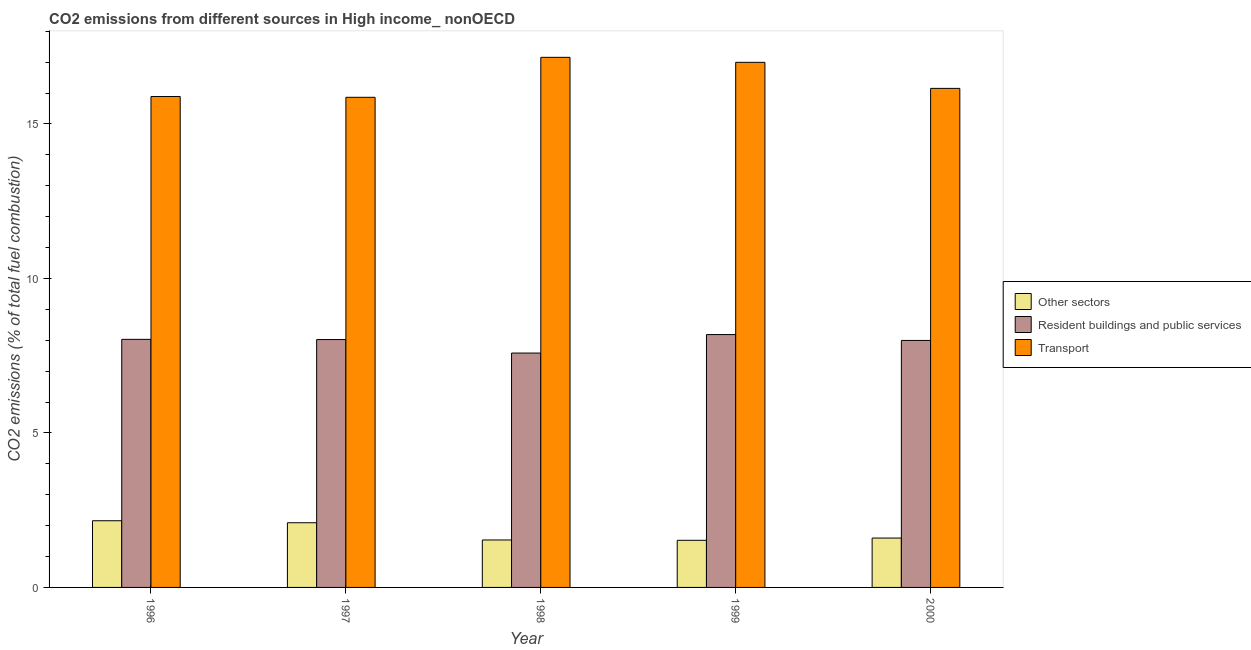How many different coloured bars are there?
Provide a succinct answer. 3. How many groups of bars are there?
Your answer should be very brief. 5. In how many cases, is the number of bars for a given year not equal to the number of legend labels?
Give a very brief answer. 0. What is the percentage of co2 emissions from other sectors in 1998?
Offer a very short reply. 1.54. Across all years, what is the maximum percentage of co2 emissions from resident buildings and public services?
Your answer should be very brief. 8.18. Across all years, what is the minimum percentage of co2 emissions from other sectors?
Provide a short and direct response. 1.53. What is the total percentage of co2 emissions from transport in the graph?
Keep it short and to the point. 82.05. What is the difference between the percentage of co2 emissions from transport in 1996 and that in 1999?
Offer a very short reply. -1.11. What is the difference between the percentage of co2 emissions from resident buildings and public services in 1999 and the percentage of co2 emissions from other sectors in 1998?
Make the answer very short. 0.6. What is the average percentage of co2 emissions from transport per year?
Provide a succinct answer. 16.41. In how many years, is the percentage of co2 emissions from other sectors greater than 15 %?
Give a very brief answer. 0. What is the ratio of the percentage of co2 emissions from resident buildings and public services in 1996 to that in 1999?
Keep it short and to the point. 0.98. What is the difference between the highest and the second highest percentage of co2 emissions from transport?
Make the answer very short. 0.16. What is the difference between the highest and the lowest percentage of co2 emissions from resident buildings and public services?
Provide a succinct answer. 0.6. Is the sum of the percentage of co2 emissions from resident buildings and public services in 1997 and 1998 greater than the maximum percentage of co2 emissions from transport across all years?
Your response must be concise. Yes. What does the 2nd bar from the left in 2000 represents?
Your answer should be compact. Resident buildings and public services. What does the 3rd bar from the right in 1998 represents?
Your answer should be very brief. Other sectors. Is it the case that in every year, the sum of the percentage of co2 emissions from other sectors and percentage of co2 emissions from resident buildings and public services is greater than the percentage of co2 emissions from transport?
Your answer should be compact. No. How many bars are there?
Your response must be concise. 15. Are all the bars in the graph horizontal?
Make the answer very short. No. Are the values on the major ticks of Y-axis written in scientific E-notation?
Provide a succinct answer. No. Does the graph contain any zero values?
Keep it short and to the point. No. Does the graph contain grids?
Provide a succinct answer. No. How many legend labels are there?
Your answer should be very brief. 3. How are the legend labels stacked?
Your answer should be compact. Vertical. What is the title of the graph?
Offer a terse response. CO2 emissions from different sources in High income_ nonOECD. Does "Labor Tax" appear as one of the legend labels in the graph?
Provide a short and direct response. No. What is the label or title of the Y-axis?
Your response must be concise. CO2 emissions (% of total fuel combustion). What is the CO2 emissions (% of total fuel combustion) of Other sectors in 1996?
Your answer should be compact. 2.16. What is the CO2 emissions (% of total fuel combustion) of Resident buildings and public services in 1996?
Provide a short and direct response. 8.03. What is the CO2 emissions (% of total fuel combustion) in Transport in 1996?
Give a very brief answer. 15.89. What is the CO2 emissions (% of total fuel combustion) in Other sectors in 1997?
Provide a succinct answer. 2.09. What is the CO2 emissions (% of total fuel combustion) of Resident buildings and public services in 1997?
Provide a short and direct response. 8.02. What is the CO2 emissions (% of total fuel combustion) of Transport in 1997?
Your answer should be compact. 15.86. What is the CO2 emissions (% of total fuel combustion) in Other sectors in 1998?
Offer a very short reply. 1.54. What is the CO2 emissions (% of total fuel combustion) of Resident buildings and public services in 1998?
Keep it short and to the point. 7.58. What is the CO2 emissions (% of total fuel combustion) in Transport in 1998?
Your answer should be very brief. 17.16. What is the CO2 emissions (% of total fuel combustion) in Other sectors in 1999?
Your answer should be very brief. 1.53. What is the CO2 emissions (% of total fuel combustion) in Resident buildings and public services in 1999?
Ensure brevity in your answer.  8.18. What is the CO2 emissions (% of total fuel combustion) in Transport in 1999?
Ensure brevity in your answer.  16.99. What is the CO2 emissions (% of total fuel combustion) in Other sectors in 2000?
Provide a short and direct response. 1.6. What is the CO2 emissions (% of total fuel combustion) of Resident buildings and public services in 2000?
Make the answer very short. 7.99. What is the CO2 emissions (% of total fuel combustion) of Transport in 2000?
Offer a terse response. 16.15. Across all years, what is the maximum CO2 emissions (% of total fuel combustion) in Other sectors?
Offer a very short reply. 2.16. Across all years, what is the maximum CO2 emissions (% of total fuel combustion) of Resident buildings and public services?
Provide a short and direct response. 8.18. Across all years, what is the maximum CO2 emissions (% of total fuel combustion) in Transport?
Keep it short and to the point. 17.16. Across all years, what is the minimum CO2 emissions (% of total fuel combustion) of Other sectors?
Give a very brief answer. 1.53. Across all years, what is the minimum CO2 emissions (% of total fuel combustion) of Resident buildings and public services?
Offer a terse response. 7.58. Across all years, what is the minimum CO2 emissions (% of total fuel combustion) in Transport?
Offer a very short reply. 15.86. What is the total CO2 emissions (% of total fuel combustion) in Other sectors in the graph?
Keep it short and to the point. 8.91. What is the total CO2 emissions (% of total fuel combustion) in Resident buildings and public services in the graph?
Offer a very short reply. 39.81. What is the total CO2 emissions (% of total fuel combustion) in Transport in the graph?
Your answer should be very brief. 82.05. What is the difference between the CO2 emissions (% of total fuel combustion) in Other sectors in 1996 and that in 1997?
Ensure brevity in your answer.  0.06. What is the difference between the CO2 emissions (% of total fuel combustion) of Resident buildings and public services in 1996 and that in 1997?
Offer a terse response. 0.01. What is the difference between the CO2 emissions (% of total fuel combustion) in Transport in 1996 and that in 1997?
Make the answer very short. 0.03. What is the difference between the CO2 emissions (% of total fuel combustion) of Other sectors in 1996 and that in 1998?
Your response must be concise. 0.62. What is the difference between the CO2 emissions (% of total fuel combustion) of Resident buildings and public services in 1996 and that in 1998?
Ensure brevity in your answer.  0.44. What is the difference between the CO2 emissions (% of total fuel combustion) of Transport in 1996 and that in 1998?
Provide a short and direct response. -1.27. What is the difference between the CO2 emissions (% of total fuel combustion) of Other sectors in 1996 and that in 1999?
Keep it short and to the point. 0.63. What is the difference between the CO2 emissions (% of total fuel combustion) of Resident buildings and public services in 1996 and that in 1999?
Give a very brief answer. -0.15. What is the difference between the CO2 emissions (% of total fuel combustion) in Transport in 1996 and that in 1999?
Keep it short and to the point. -1.11. What is the difference between the CO2 emissions (% of total fuel combustion) of Other sectors in 1996 and that in 2000?
Make the answer very short. 0.56. What is the difference between the CO2 emissions (% of total fuel combustion) in Resident buildings and public services in 1996 and that in 2000?
Your answer should be very brief. 0.03. What is the difference between the CO2 emissions (% of total fuel combustion) in Transport in 1996 and that in 2000?
Provide a succinct answer. -0.26. What is the difference between the CO2 emissions (% of total fuel combustion) of Other sectors in 1997 and that in 1998?
Offer a terse response. 0.56. What is the difference between the CO2 emissions (% of total fuel combustion) in Resident buildings and public services in 1997 and that in 1998?
Your answer should be compact. 0.44. What is the difference between the CO2 emissions (% of total fuel combustion) in Transport in 1997 and that in 1998?
Offer a very short reply. -1.29. What is the difference between the CO2 emissions (% of total fuel combustion) of Other sectors in 1997 and that in 1999?
Make the answer very short. 0.57. What is the difference between the CO2 emissions (% of total fuel combustion) of Resident buildings and public services in 1997 and that in 1999?
Provide a short and direct response. -0.16. What is the difference between the CO2 emissions (% of total fuel combustion) in Transport in 1997 and that in 1999?
Ensure brevity in your answer.  -1.13. What is the difference between the CO2 emissions (% of total fuel combustion) in Other sectors in 1997 and that in 2000?
Provide a succinct answer. 0.5. What is the difference between the CO2 emissions (% of total fuel combustion) of Resident buildings and public services in 1997 and that in 2000?
Provide a succinct answer. 0.03. What is the difference between the CO2 emissions (% of total fuel combustion) in Transport in 1997 and that in 2000?
Offer a very short reply. -0.29. What is the difference between the CO2 emissions (% of total fuel combustion) of Other sectors in 1998 and that in 1999?
Keep it short and to the point. 0.01. What is the difference between the CO2 emissions (% of total fuel combustion) in Resident buildings and public services in 1998 and that in 1999?
Offer a terse response. -0.6. What is the difference between the CO2 emissions (% of total fuel combustion) of Transport in 1998 and that in 1999?
Ensure brevity in your answer.  0.16. What is the difference between the CO2 emissions (% of total fuel combustion) in Other sectors in 1998 and that in 2000?
Ensure brevity in your answer.  -0.06. What is the difference between the CO2 emissions (% of total fuel combustion) in Resident buildings and public services in 1998 and that in 2000?
Your response must be concise. -0.41. What is the difference between the CO2 emissions (% of total fuel combustion) in Transport in 1998 and that in 2000?
Keep it short and to the point. 1. What is the difference between the CO2 emissions (% of total fuel combustion) of Other sectors in 1999 and that in 2000?
Give a very brief answer. -0.07. What is the difference between the CO2 emissions (% of total fuel combustion) of Resident buildings and public services in 1999 and that in 2000?
Ensure brevity in your answer.  0.19. What is the difference between the CO2 emissions (% of total fuel combustion) in Transport in 1999 and that in 2000?
Give a very brief answer. 0.84. What is the difference between the CO2 emissions (% of total fuel combustion) in Other sectors in 1996 and the CO2 emissions (% of total fuel combustion) in Resident buildings and public services in 1997?
Ensure brevity in your answer.  -5.86. What is the difference between the CO2 emissions (% of total fuel combustion) in Other sectors in 1996 and the CO2 emissions (% of total fuel combustion) in Transport in 1997?
Provide a succinct answer. -13.7. What is the difference between the CO2 emissions (% of total fuel combustion) of Resident buildings and public services in 1996 and the CO2 emissions (% of total fuel combustion) of Transport in 1997?
Offer a terse response. -7.83. What is the difference between the CO2 emissions (% of total fuel combustion) in Other sectors in 1996 and the CO2 emissions (% of total fuel combustion) in Resident buildings and public services in 1998?
Your answer should be very brief. -5.43. What is the difference between the CO2 emissions (% of total fuel combustion) of Other sectors in 1996 and the CO2 emissions (% of total fuel combustion) of Transport in 1998?
Your answer should be very brief. -15. What is the difference between the CO2 emissions (% of total fuel combustion) in Resident buildings and public services in 1996 and the CO2 emissions (% of total fuel combustion) in Transport in 1998?
Provide a short and direct response. -9.13. What is the difference between the CO2 emissions (% of total fuel combustion) in Other sectors in 1996 and the CO2 emissions (% of total fuel combustion) in Resident buildings and public services in 1999?
Offer a very short reply. -6.03. What is the difference between the CO2 emissions (% of total fuel combustion) in Other sectors in 1996 and the CO2 emissions (% of total fuel combustion) in Transport in 1999?
Provide a short and direct response. -14.84. What is the difference between the CO2 emissions (% of total fuel combustion) of Resident buildings and public services in 1996 and the CO2 emissions (% of total fuel combustion) of Transport in 1999?
Ensure brevity in your answer.  -8.96. What is the difference between the CO2 emissions (% of total fuel combustion) of Other sectors in 1996 and the CO2 emissions (% of total fuel combustion) of Resident buildings and public services in 2000?
Offer a terse response. -5.84. What is the difference between the CO2 emissions (% of total fuel combustion) of Other sectors in 1996 and the CO2 emissions (% of total fuel combustion) of Transport in 2000?
Your answer should be compact. -13.99. What is the difference between the CO2 emissions (% of total fuel combustion) of Resident buildings and public services in 1996 and the CO2 emissions (% of total fuel combustion) of Transport in 2000?
Your response must be concise. -8.12. What is the difference between the CO2 emissions (% of total fuel combustion) in Other sectors in 1997 and the CO2 emissions (% of total fuel combustion) in Resident buildings and public services in 1998?
Ensure brevity in your answer.  -5.49. What is the difference between the CO2 emissions (% of total fuel combustion) in Other sectors in 1997 and the CO2 emissions (% of total fuel combustion) in Transport in 1998?
Keep it short and to the point. -15.06. What is the difference between the CO2 emissions (% of total fuel combustion) of Resident buildings and public services in 1997 and the CO2 emissions (% of total fuel combustion) of Transport in 1998?
Ensure brevity in your answer.  -9.13. What is the difference between the CO2 emissions (% of total fuel combustion) in Other sectors in 1997 and the CO2 emissions (% of total fuel combustion) in Resident buildings and public services in 1999?
Ensure brevity in your answer.  -6.09. What is the difference between the CO2 emissions (% of total fuel combustion) in Other sectors in 1997 and the CO2 emissions (% of total fuel combustion) in Transport in 1999?
Ensure brevity in your answer.  -14.9. What is the difference between the CO2 emissions (% of total fuel combustion) in Resident buildings and public services in 1997 and the CO2 emissions (% of total fuel combustion) in Transport in 1999?
Your answer should be very brief. -8.97. What is the difference between the CO2 emissions (% of total fuel combustion) in Other sectors in 1997 and the CO2 emissions (% of total fuel combustion) in Resident buildings and public services in 2000?
Your response must be concise. -5.9. What is the difference between the CO2 emissions (% of total fuel combustion) of Other sectors in 1997 and the CO2 emissions (% of total fuel combustion) of Transport in 2000?
Ensure brevity in your answer.  -14.06. What is the difference between the CO2 emissions (% of total fuel combustion) in Resident buildings and public services in 1997 and the CO2 emissions (% of total fuel combustion) in Transport in 2000?
Give a very brief answer. -8.13. What is the difference between the CO2 emissions (% of total fuel combustion) in Other sectors in 1998 and the CO2 emissions (% of total fuel combustion) in Resident buildings and public services in 1999?
Offer a terse response. -6.65. What is the difference between the CO2 emissions (% of total fuel combustion) in Other sectors in 1998 and the CO2 emissions (% of total fuel combustion) in Transport in 1999?
Your answer should be very brief. -15.46. What is the difference between the CO2 emissions (% of total fuel combustion) of Resident buildings and public services in 1998 and the CO2 emissions (% of total fuel combustion) of Transport in 1999?
Offer a very short reply. -9.41. What is the difference between the CO2 emissions (% of total fuel combustion) in Other sectors in 1998 and the CO2 emissions (% of total fuel combustion) in Resident buildings and public services in 2000?
Provide a short and direct response. -6.46. What is the difference between the CO2 emissions (% of total fuel combustion) of Other sectors in 1998 and the CO2 emissions (% of total fuel combustion) of Transport in 2000?
Ensure brevity in your answer.  -14.61. What is the difference between the CO2 emissions (% of total fuel combustion) of Resident buildings and public services in 1998 and the CO2 emissions (% of total fuel combustion) of Transport in 2000?
Ensure brevity in your answer.  -8.57. What is the difference between the CO2 emissions (% of total fuel combustion) in Other sectors in 1999 and the CO2 emissions (% of total fuel combustion) in Resident buildings and public services in 2000?
Provide a succinct answer. -6.47. What is the difference between the CO2 emissions (% of total fuel combustion) of Other sectors in 1999 and the CO2 emissions (% of total fuel combustion) of Transport in 2000?
Give a very brief answer. -14.63. What is the difference between the CO2 emissions (% of total fuel combustion) of Resident buildings and public services in 1999 and the CO2 emissions (% of total fuel combustion) of Transport in 2000?
Offer a very short reply. -7.97. What is the average CO2 emissions (% of total fuel combustion) in Other sectors per year?
Your answer should be very brief. 1.78. What is the average CO2 emissions (% of total fuel combustion) of Resident buildings and public services per year?
Provide a succinct answer. 7.96. What is the average CO2 emissions (% of total fuel combustion) in Transport per year?
Provide a short and direct response. 16.41. In the year 1996, what is the difference between the CO2 emissions (% of total fuel combustion) of Other sectors and CO2 emissions (% of total fuel combustion) of Resident buildings and public services?
Offer a very short reply. -5.87. In the year 1996, what is the difference between the CO2 emissions (% of total fuel combustion) in Other sectors and CO2 emissions (% of total fuel combustion) in Transport?
Provide a short and direct response. -13.73. In the year 1996, what is the difference between the CO2 emissions (% of total fuel combustion) of Resident buildings and public services and CO2 emissions (% of total fuel combustion) of Transport?
Offer a terse response. -7.86. In the year 1997, what is the difference between the CO2 emissions (% of total fuel combustion) in Other sectors and CO2 emissions (% of total fuel combustion) in Resident buildings and public services?
Give a very brief answer. -5.93. In the year 1997, what is the difference between the CO2 emissions (% of total fuel combustion) in Other sectors and CO2 emissions (% of total fuel combustion) in Transport?
Provide a succinct answer. -13.77. In the year 1997, what is the difference between the CO2 emissions (% of total fuel combustion) in Resident buildings and public services and CO2 emissions (% of total fuel combustion) in Transport?
Provide a succinct answer. -7.84. In the year 1998, what is the difference between the CO2 emissions (% of total fuel combustion) of Other sectors and CO2 emissions (% of total fuel combustion) of Resident buildings and public services?
Provide a short and direct response. -6.05. In the year 1998, what is the difference between the CO2 emissions (% of total fuel combustion) of Other sectors and CO2 emissions (% of total fuel combustion) of Transport?
Keep it short and to the point. -15.62. In the year 1998, what is the difference between the CO2 emissions (% of total fuel combustion) of Resident buildings and public services and CO2 emissions (% of total fuel combustion) of Transport?
Ensure brevity in your answer.  -9.57. In the year 1999, what is the difference between the CO2 emissions (% of total fuel combustion) in Other sectors and CO2 emissions (% of total fuel combustion) in Resident buildings and public services?
Provide a succinct answer. -6.66. In the year 1999, what is the difference between the CO2 emissions (% of total fuel combustion) in Other sectors and CO2 emissions (% of total fuel combustion) in Transport?
Keep it short and to the point. -15.47. In the year 1999, what is the difference between the CO2 emissions (% of total fuel combustion) in Resident buildings and public services and CO2 emissions (% of total fuel combustion) in Transport?
Ensure brevity in your answer.  -8.81. In the year 2000, what is the difference between the CO2 emissions (% of total fuel combustion) of Other sectors and CO2 emissions (% of total fuel combustion) of Resident buildings and public services?
Your response must be concise. -6.4. In the year 2000, what is the difference between the CO2 emissions (% of total fuel combustion) in Other sectors and CO2 emissions (% of total fuel combustion) in Transport?
Offer a very short reply. -14.55. In the year 2000, what is the difference between the CO2 emissions (% of total fuel combustion) in Resident buildings and public services and CO2 emissions (% of total fuel combustion) in Transport?
Provide a short and direct response. -8.16. What is the ratio of the CO2 emissions (% of total fuel combustion) in Other sectors in 1996 to that in 1997?
Ensure brevity in your answer.  1.03. What is the ratio of the CO2 emissions (% of total fuel combustion) of Transport in 1996 to that in 1997?
Your answer should be very brief. 1. What is the ratio of the CO2 emissions (% of total fuel combustion) in Other sectors in 1996 to that in 1998?
Your answer should be compact. 1.41. What is the ratio of the CO2 emissions (% of total fuel combustion) of Resident buildings and public services in 1996 to that in 1998?
Give a very brief answer. 1.06. What is the ratio of the CO2 emissions (% of total fuel combustion) in Transport in 1996 to that in 1998?
Offer a very short reply. 0.93. What is the ratio of the CO2 emissions (% of total fuel combustion) of Other sectors in 1996 to that in 1999?
Your response must be concise. 1.41. What is the ratio of the CO2 emissions (% of total fuel combustion) in Resident buildings and public services in 1996 to that in 1999?
Keep it short and to the point. 0.98. What is the ratio of the CO2 emissions (% of total fuel combustion) of Transport in 1996 to that in 1999?
Offer a very short reply. 0.93. What is the ratio of the CO2 emissions (% of total fuel combustion) in Other sectors in 1996 to that in 2000?
Make the answer very short. 1.35. What is the ratio of the CO2 emissions (% of total fuel combustion) in Resident buildings and public services in 1996 to that in 2000?
Your answer should be compact. 1. What is the ratio of the CO2 emissions (% of total fuel combustion) of Transport in 1996 to that in 2000?
Your response must be concise. 0.98. What is the ratio of the CO2 emissions (% of total fuel combustion) in Other sectors in 1997 to that in 1998?
Your response must be concise. 1.36. What is the ratio of the CO2 emissions (% of total fuel combustion) of Resident buildings and public services in 1997 to that in 1998?
Offer a terse response. 1.06. What is the ratio of the CO2 emissions (% of total fuel combustion) of Transport in 1997 to that in 1998?
Provide a succinct answer. 0.92. What is the ratio of the CO2 emissions (% of total fuel combustion) of Other sectors in 1997 to that in 1999?
Your answer should be very brief. 1.37. What is the ratio of the CO2 emissions (% of total fuel combustion) of Resident buildings and public services in 1997 to that in 1999?
Give a very brief answer. 0.98. What is the ratio of the CO2 emissions (% of total fuel combustion) in Transport in 1997 to that in 1999?
Give a very brief answer. 0.93. What is the ratio of the CO2 emissions (% of total fuel combustion) of Other sectors in 1997 to that in 2000?
Your answer should be compact. 1.31. What is the ratio of the CO2 emissions (% of total fuel combustion) in Resident buildings and public services in 1997 to that in 2000?
Make the answer very short. 1. What is the ratio of the CO2 emissions (% of total fuel combustion) of Transport in 1997 to that in 2000?
Keep it short and to the point. 0.98. What is the ratio of the CO2 emissions (% of total fuel combustion) of Other sectors in 1998 to that in 1999?
Give a very brief answer. 1.01. What is the ratio of the CO2 emissions (% of total fuel combustion) in Resident buildings and public services in 1998 to that in 1999?
Make the answer very short. 0.93. What is the ratio of the CO2 emissions (% of total fuel combustion) of Transport in 1998 to that in 1999?
Give a very brief answer. 1.01. What is the ratio of the CO2 emissions (% of total fuel combustion) of Other sectors in 1998 to that in 2000?
Make the answer very short. 0.96. What is the ratio of the CO2 emissions (% of total fuel combustion) of Resident buildings and public services in 1998 to that in 2000?
Ensure brevity in your answer.  0.95. What is the ratio of the CO2 emissions (% of total fuel combustion) in Transport in 1998 to that in 2000?
Your answer should be very brief. 1.06. What is the ratio of the CO2 emissions (% of total fuel combustion) of Other sectors in 1999 to that in 2000?
Give a very brief answer. 0.95. What is the ratio of the CO2 emissions (% of total fuel combustion) of Resident buildings and public services in 1999 to that in 2000?
Offer a very short reply. 1.02. What is the ratio of the CO2 emissions (% of total fuel combustion) in Transport in 1999 to that in 2000?
Provide a succinct answer. 1.05. What is the difference between the highest and the second highest CO2 emissions (% of total fuel combustion) in Other sectors?
Offer a very short reply. 0.06. What is the difference between the highest and the second highest CO2 emissions (% of total fuel combustion) in Resident buildings and public services?
Offer a very short reply. 0.15. What is the difference between the highest and the second highest CO2 emissions (% of total fuel combustion) of Transport?
Offer a terse response. 0.16. What is the difference between the highest and the lowest CO2 emissions (% of total fuel combustion) in Other sectors?
Offer a very short reply. 0.63. What is the difference between the highest and the lowest CO2 emissions (% of total fuel combustion) of Resident buildings and public services?
Your answer should be compact. 0.6. What is the difference between the highest and the lowest CO2 emissions (% of total fuel combustion) of Transport?
Your answer should be very brief. 1.29. 